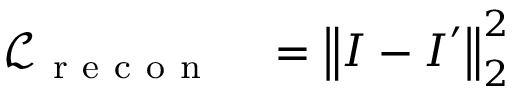<formula> <loc_0><loc_0><loc_500><loc_500>\begin{array} { r l } { \mathcal { L } _ { r e c o n } } & = \left \| I - I ^ { \prime } \right \| _ { 2 } ^ { 2 } } \end{array}</formula> 